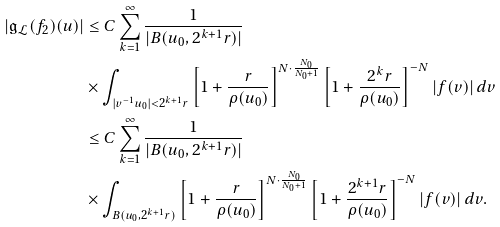Convert formula to latex. <formula><loc_0><loc_0><loc_500><loc_500>\left | \mathfrak { g } _ { \mathcal { L } } ( f _ { 2 } ) ( u ) \right | & \leq C \sum _ { k = 1 } ^ { \infty } \frac { 1 } { | B ( u _ { 0 } , 2 ^ { k + 1 } r ) | } \\ & \times \int _ { | v ^ { - 1 } u _ { 0 } | < 2 ^ { k + 1 } r } \left [ 1 + \frac { r } { \rho ( u _ { 0 } ) } \right ] ^ { N \cdot \frac { N _ { 0 } } { N _ { 0 } + 1 } } \left [ 1 + \frac { 2 ^ { k } r } { \rho ( u _ { 0 } ) } \right ] ^ { - N } | f ( v ) | \, d v \\ & \leq C \sum _ { k = 1 } ^ { \infty } \frac { 1 } { | B ( u _ { 0 } , 2 ^ { k + 1 } r ) | } \\ & \times \int _ { B ( u _ { 0 } , 2 ^ { k + 1 } r ) } \left [ 1 + \frac { r } { \rho ( u _ { 0 } ) } \right ] ^ { N \cdot \frac { N _ { 0 } } { N _ { 0 } + 1 } } \left [ 1 + \frac { 2 ^ { k + 1 } r } { \rho ( u _ { 0 } ) } \right ] ^ { - N } | f ( v ) | \, d v .</formula> 